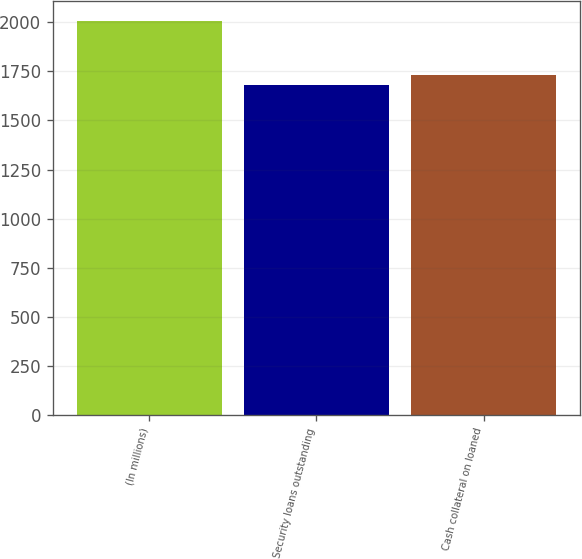Convert chart. <chart><loc_0><loc_0><loc_500><loc_500><bar_chart><fcel>(In millions)<fcel>Security loans outstanding<fcel>Cash collateral on loaned<nl><fcel>2008<fcel>1679<fcel>1733<nl></chart> 